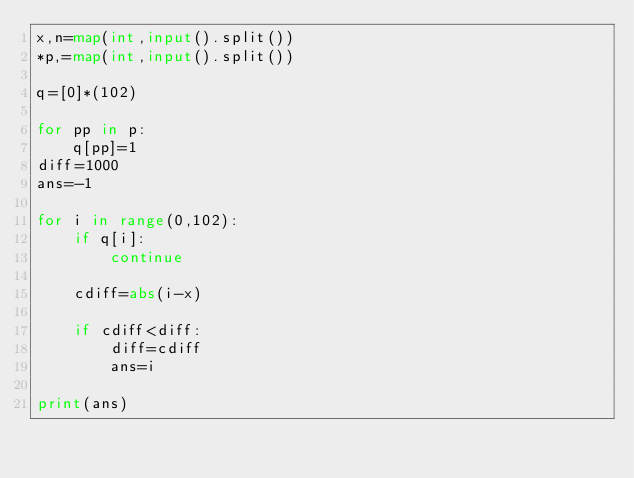<code> <loc_0><loc_0><loc_500><loc_500><_Python_>x,n=map(int,input().split())
*p,=map(int,input().split())

q=[0]*(102)

for pp in p:
    q[pp]=1
diff=1000
ans=-1

for i in range(0,102):
    if q[i]:
        continue

    cdiff=abs(i-x)

    if cdiff<diff:
        diff=cdiff
        ans=i
    
print(ans)</code> 